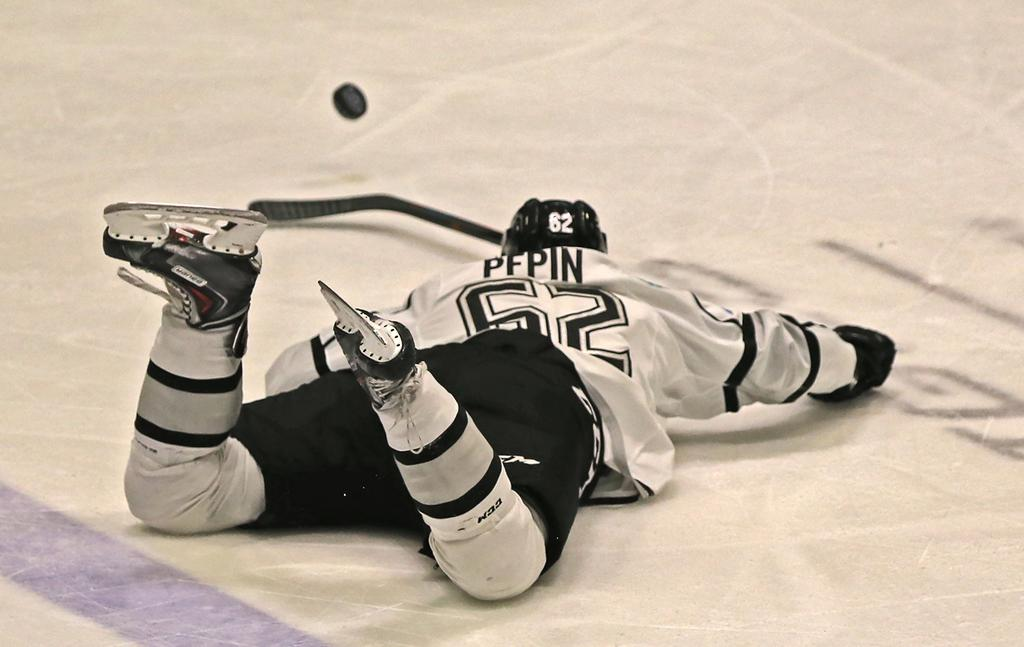Provide a one-sentence caption for the provided image. An icehockey player called Pepin wearing black and white is sprawled on the ice watching the puck scoot away from him. 